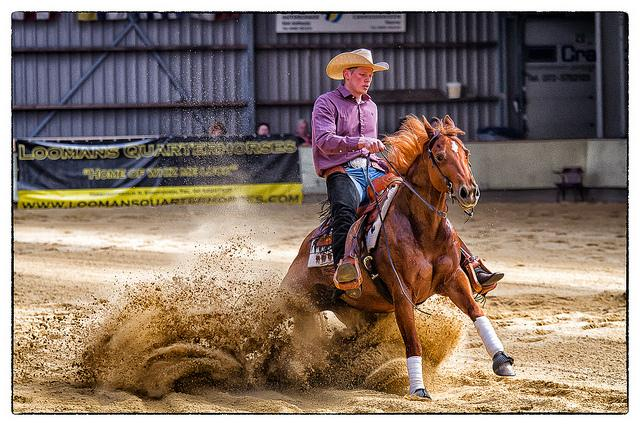What mythological creature is most similar to the one the man is riding on?

Choices:
A) phlegon
B) medusa
C) cerberus
D) airavata phlegon 